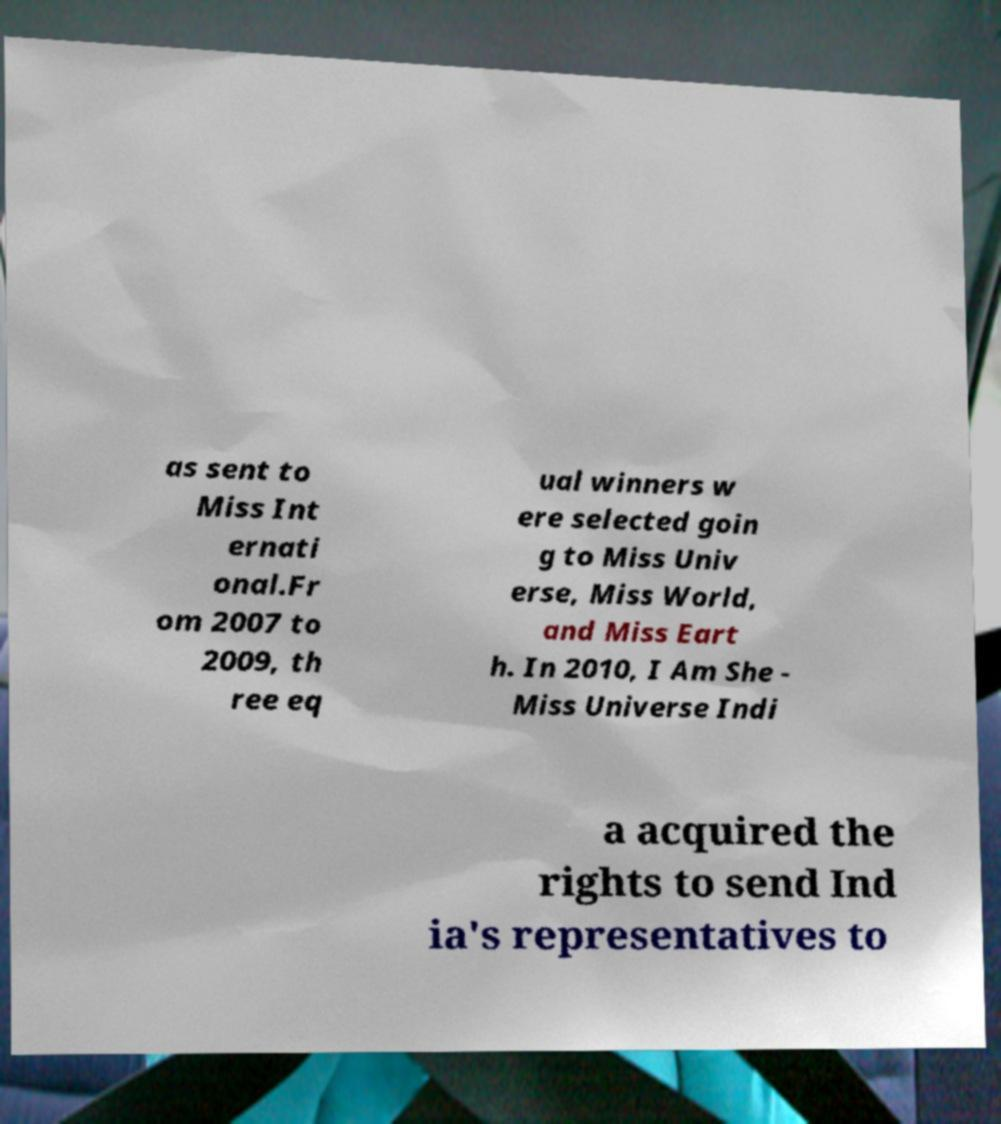What messages or text are displayed in this image? I need them in a readable, typed format. as sent to Miss Int ernati onal.Fr om 2007 to 2009, th ree eq ual winners w ere selected goin g to Miss Univ erse, Miss World, and Miss Eart h. In 2010, I Am She - Miss Universe Indi a acquired the rights to send Ind ia's representatives to 